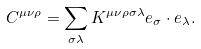Convert formula to latex. <formula><loc_0><loc_0><loc_500><loc_500>C ^ { \mu \nu \rho } = \sum _ { \sigma \lambda } K ^ { \mu \nu \rho \sigma \lambda } { e _ { \sigma } } \cdot { e _ { \lambda } } .</formula> 